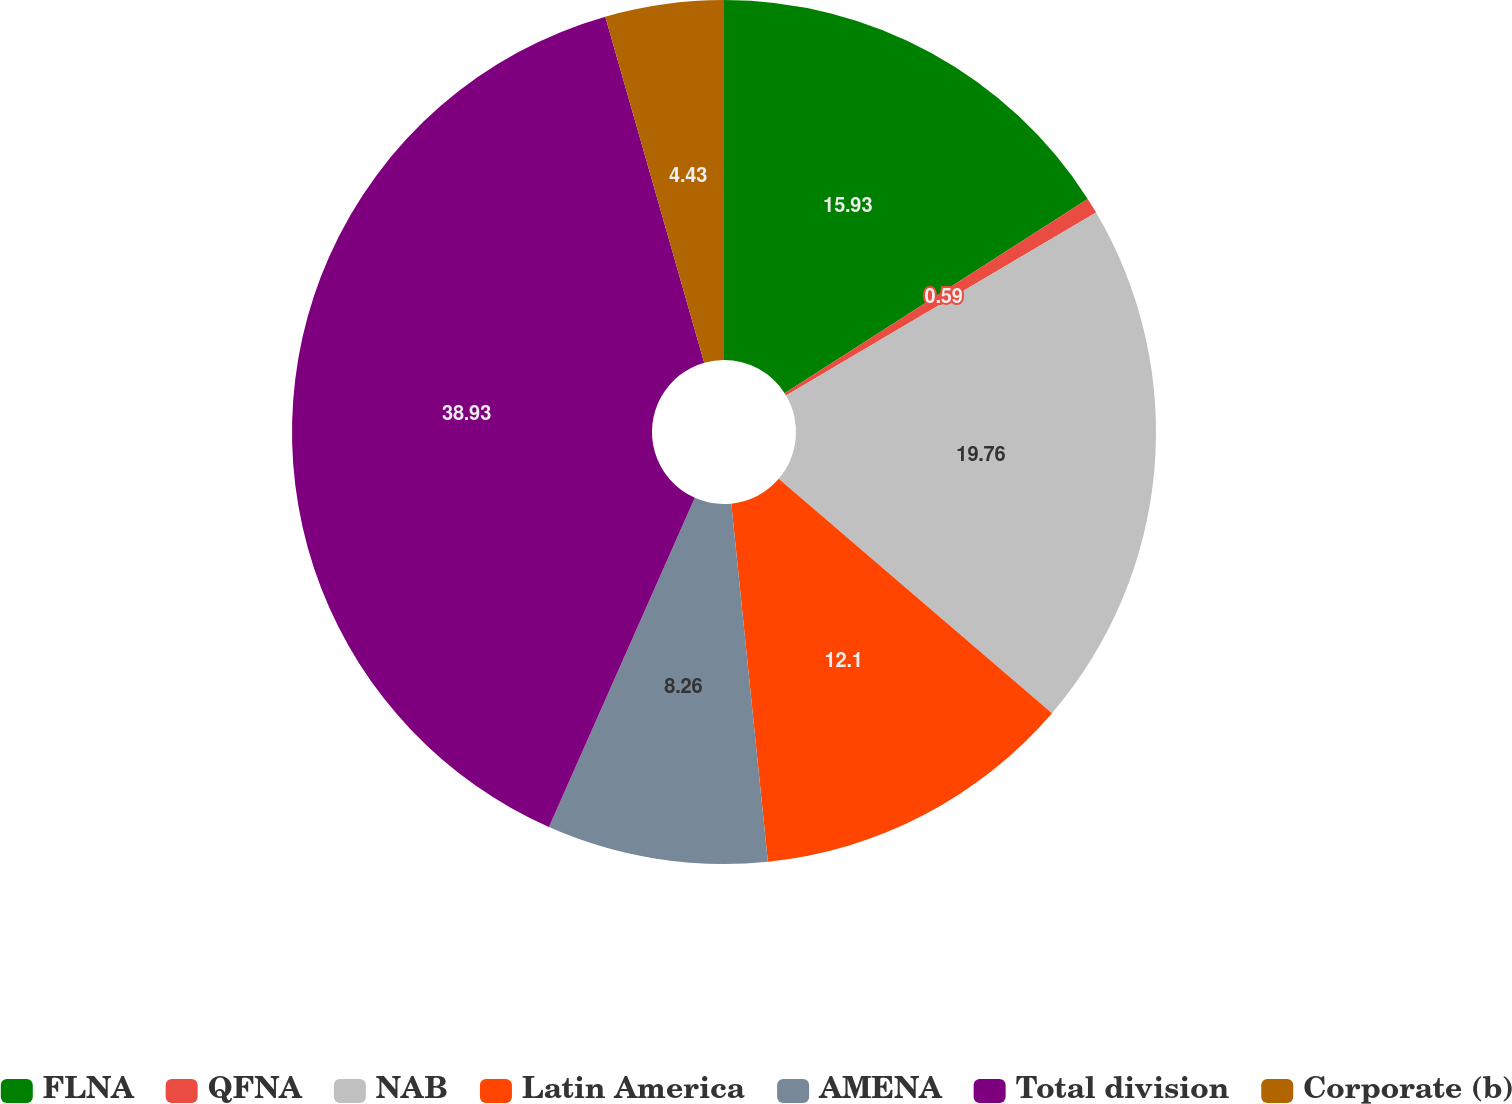Convert chart. <chart><loc_0><loc_0><loc_500><loc_500><pie_chart><fcel>FLNA<fcel>QFNA<fcel>NAB<fcel>Latin America<fcel>AMENA<fcel>Total division<fcel>Corporate (b)<nl><fcel>15.93%<fcel>0.59%<fcel>19.76%<fcel>12.1%<fcel>8.26%<fcel>38.93%<fcel>4.43%<nl></chart> 